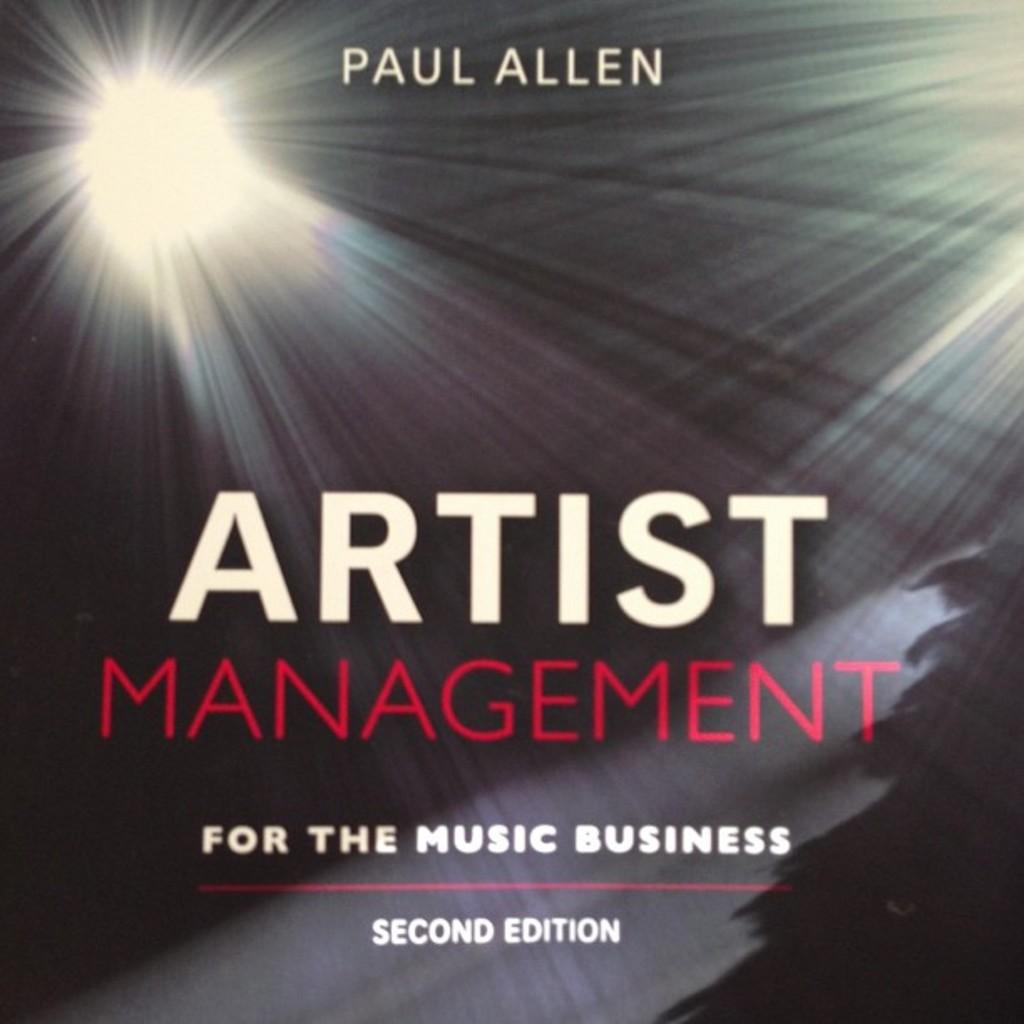<image>
Share a concise interpretation of the image provided. an album cover for Paul Allen about artist managemnt for the music business 